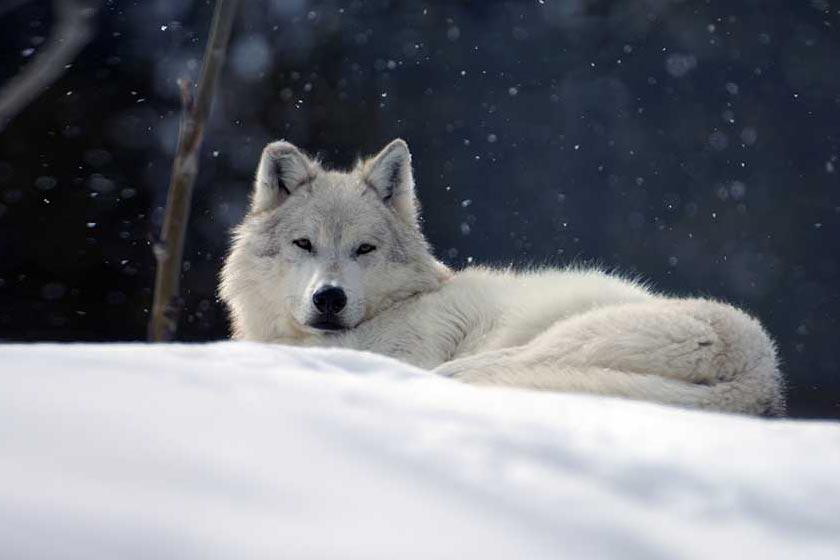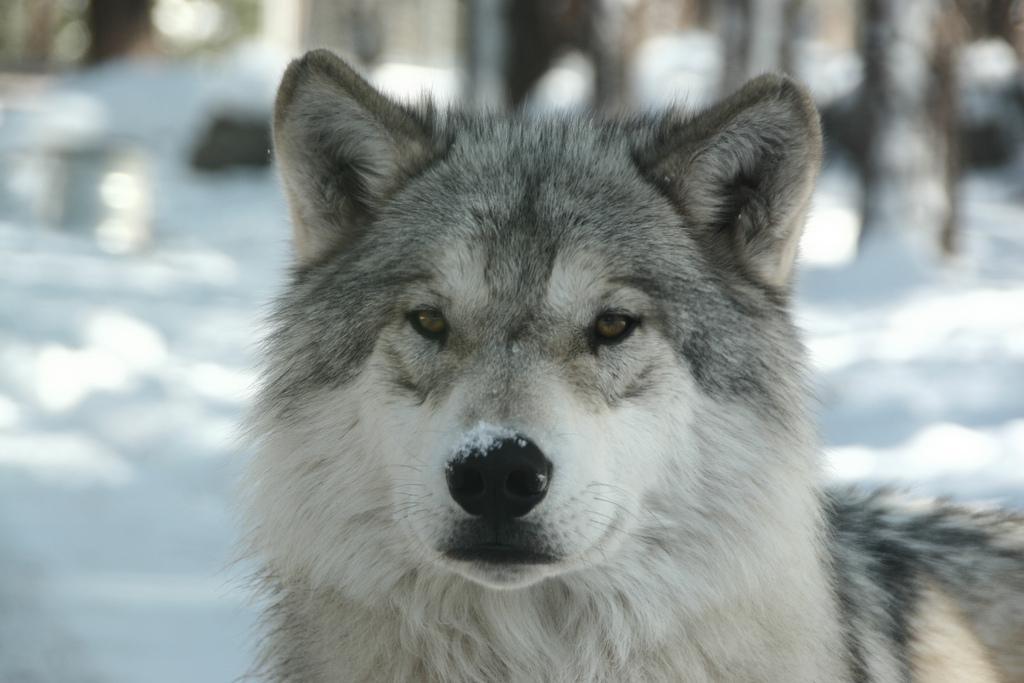The first image is the image on the left, the second image is the image on the right. Evaluate the accuracy of this statement regarding the images: "There is exactly four wolves in the right image.". Is it true? Answer yes or no. No. The first image is the image on the left, the second image is the image on the right. Analyze the images presented: Is the assertion "At least one dog has its front paws standing in a pool of water surrounded by rocks and green grass." valid? Answer yes or no. No. 